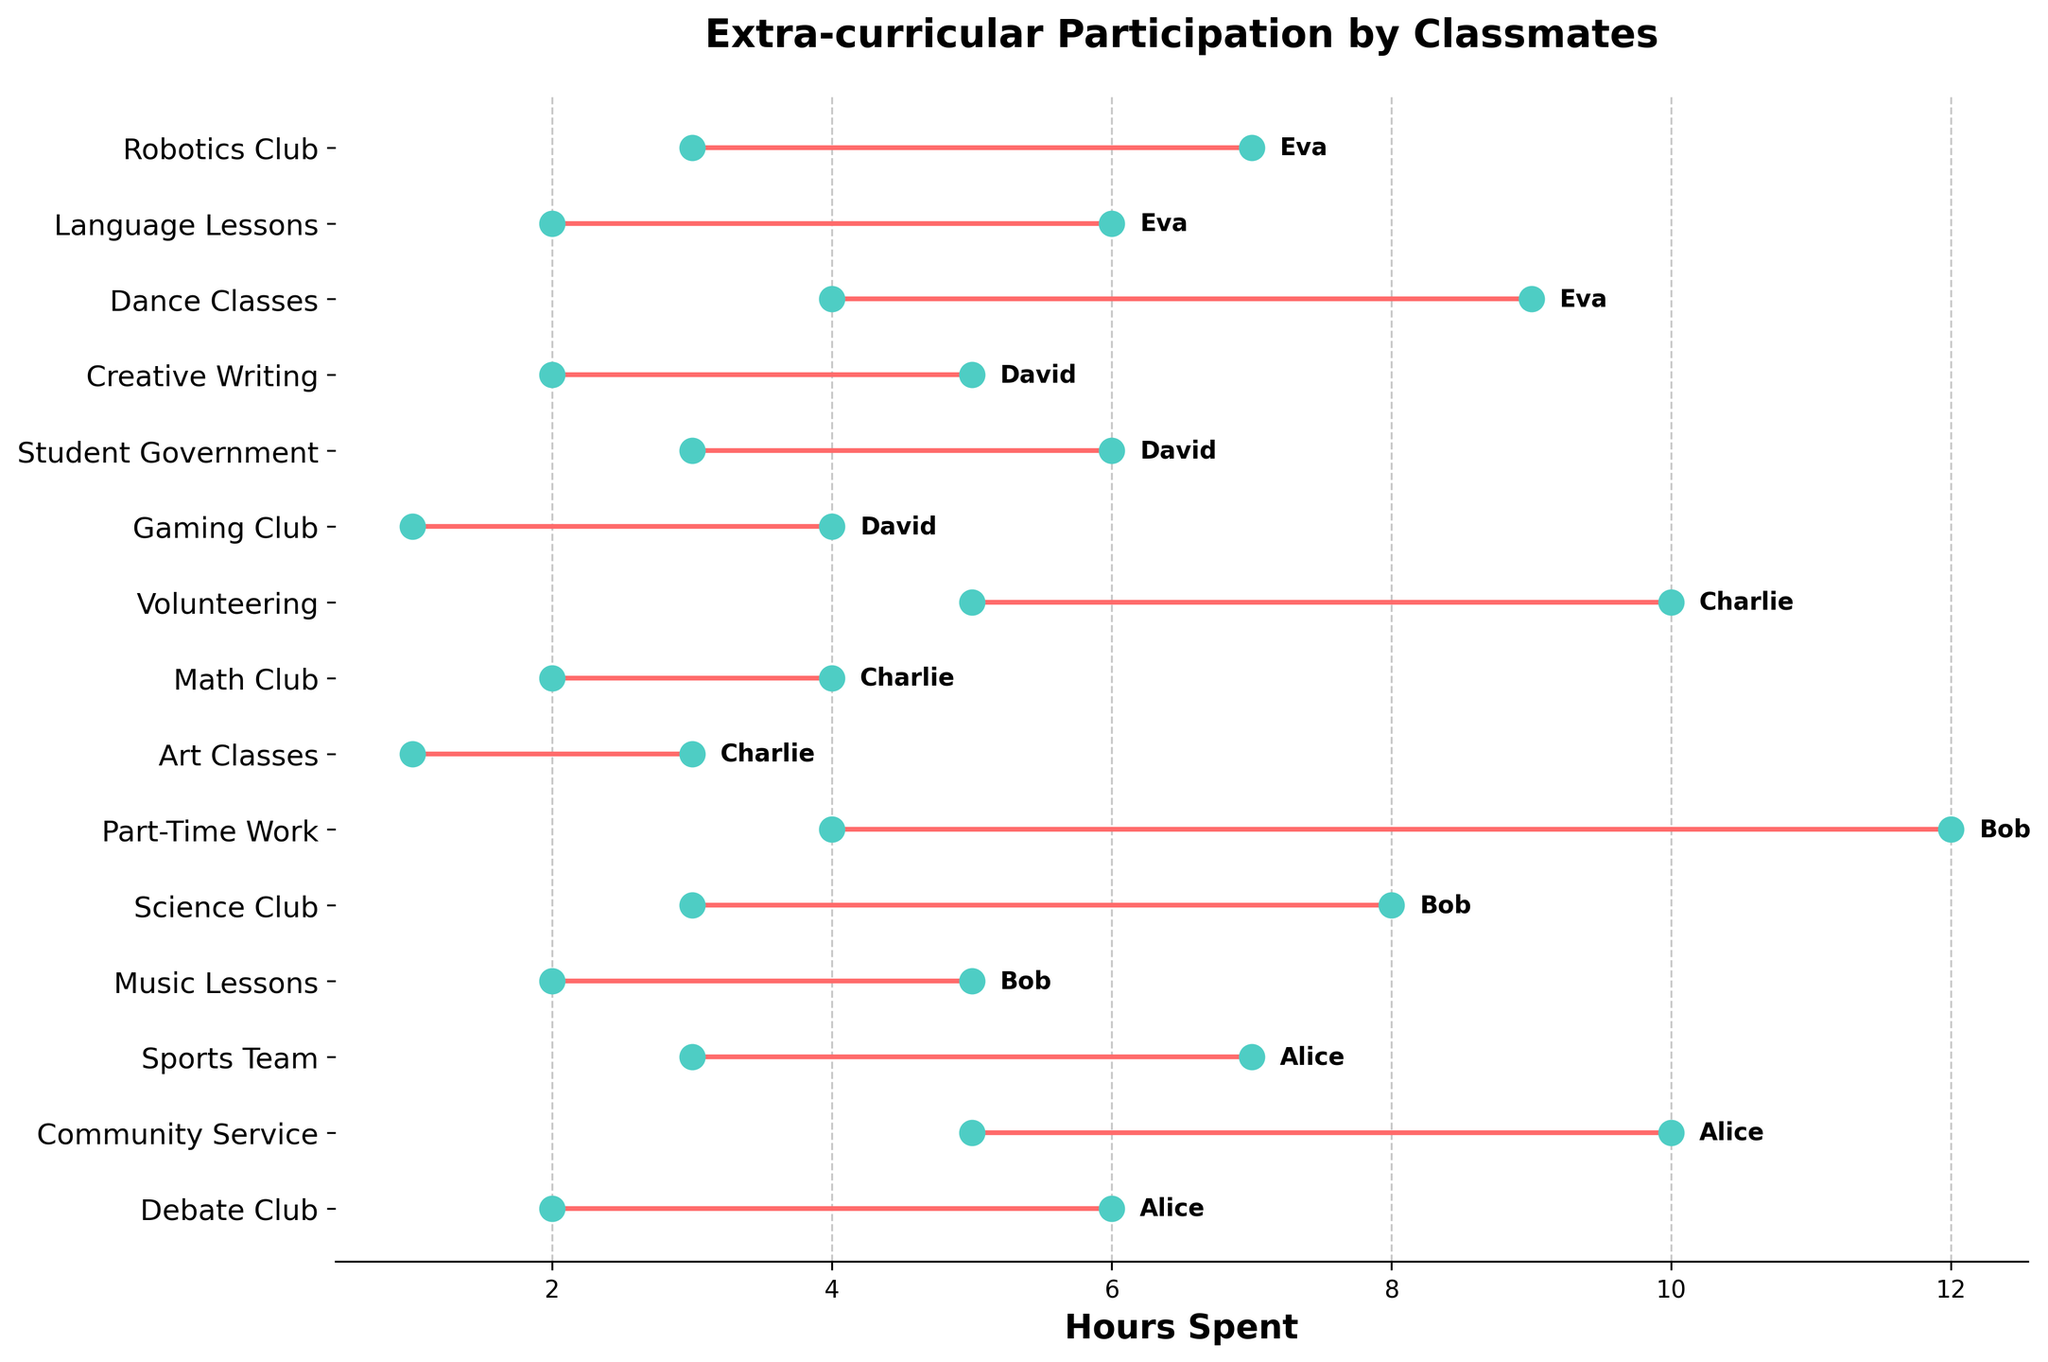What is the title of the plot? The title can be seen at the top of the plot. It reads "Extra-curricular Participation by Classmates."
Answer: Extra-curricular Participation by Classmates What does the x-axis represent? The label on the x-axis indicates it represents the hours spent on different activities.
Answer: Hours Spent How many activities does Alice participate in? By visually scanning for Alice's name in the plot, we can count the number of horizontal lines connected to her name. There are three activities listed.
Answer: 3 Which activity has the maximum range of hours spent by any one student and who is the student? The range is determined by the difference between the Max_Hours and Min_Hours for each activity. Bob's Part-Time Work has the maximum range of 8 hours (12 - 4).
Answer: Part-Time Work, Bob Who spends the most hours on a single activity, and what is that activity? By checking the Max_Hours labels and matching them to the student's name, Bob spends the most hours, up to 12, on Part-Time Work.
Answer: Bob, Part-Time Work Compare the maximum hours spent by Eva and Alice on their most time-consuming activities. Who spends more and by how many hours? Eva's most time-consuming activity is Dance Classes (9 hours max), and Alice's is Community Service (10 hours max). Comparing these, Alice spends 1 more hour.
Answer: Alice, 1 hour What is the average minimum hours spent on Math Club and Volunteering by Charlie? Calculate by summing up the Min_Hours for both activities and dividing by the number of activities: (2+5)/2 = 3.5 hours.
Answer: 3.5 hours Is there any activity where multiple students have the same maximum hours? By scanning the Max_Hours values for different students and comparing them, we can see that Community Service (Alice) and Volunteering (Charlie) both have Max_Hours of 10.
Answer: Yes Which student has the smallest range of hours spent on an activity, and what is the activity? Calculate the range (Max_Hours - Min_Hours) for each student and identify the smallest value. Charlie's Art Classes has the smallest range of 2 hours (3 - 1).
Answer: Charlie, Art Classes How does the range of hours spent on Creative Writing compare with Gaming Club for David? David's Creative Writing has a range of 3 hours (5-2) and Gaming Club has a range of 3 hours (4-1). Both activities have the same range.
Answer: Same range 